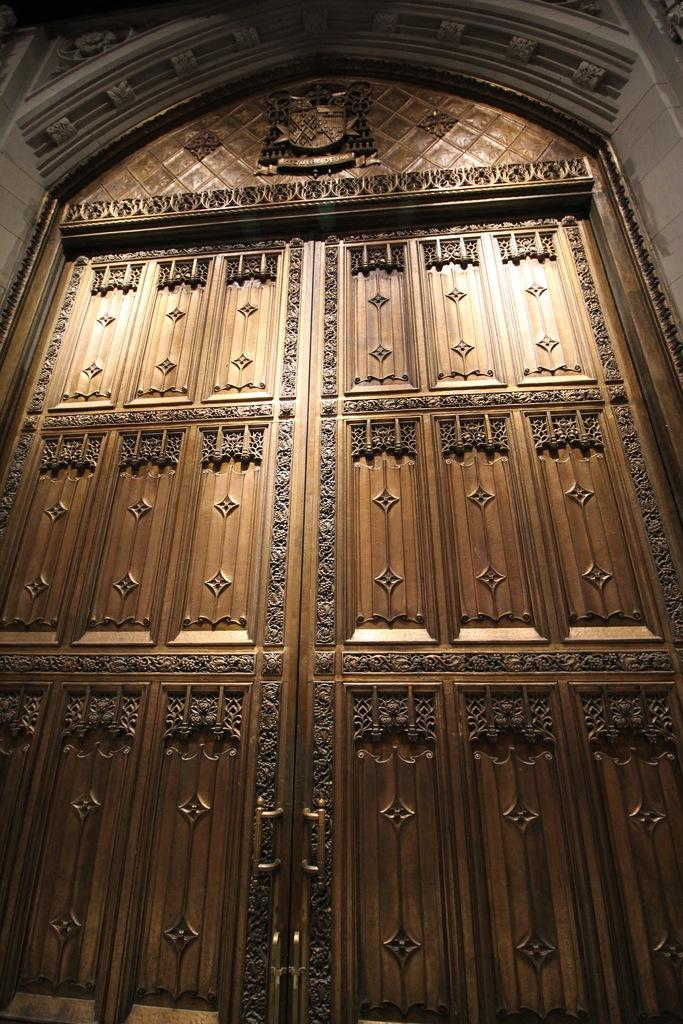What is a prominent feature in the image? There is a door in the image. Can you describe the door's design? The door has a unique or different design. How does the arm of the person in the image talk about the door's design? There is no person or arm present in the image, so it is not possible to answer that question. 